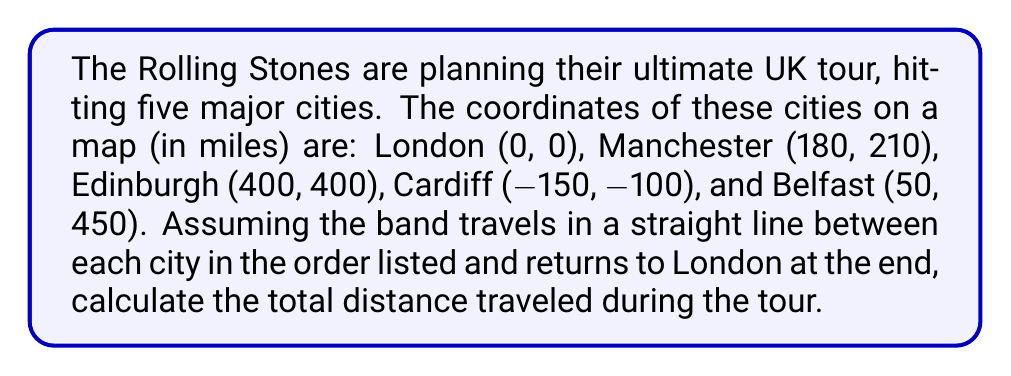What is the answer to this math problem? Let's approach this step-by-step using the distance formula between two points: $d = \sqrt{(x_2-x_1)^2 + (y_2-y_1)^2}$

1) London to Manchester:
   $d_1 = \sqrt{(180-0)^2 + (210-0)^2} = \sqrt{32400 + 44100} = \sqrt{76500} \approx 276.59$ miles

2) Manchester to Edinburgh:
   $d_2 = \sqrt{(400-180)^2 + (400-210)^2} = \sqrt{48400 + 36100} = \sqrt{84500} \approx 290.69$ miles

3) Edinburgh to Cardiff:
   $d_3 = \sqrt{(-150-400)^2 + (-100-400)^2} = \sqrt{302500 + 250000} = \sqrt{552500} \approx 743.30$ miles

4) Cardiff to Belfast:
   $d_4 = \sqrt{(50-(-150))^2 + (450-(-100))^2} = \sqrt{40000 + 302500} = \sqrt{342500} \approx 585.23$ miles

5) Belfast back to London:
   $d_5 = \sqrt{(0-50)^2 + (0-450)^2} = \sqrt{2500 + 202500} = \sqrt{205000} \approx 452.77$ miles

Total distance = $d_1 + d_2 + d_3 + d_4 + d_5$
                $\approx 276.59 + 290.69 + 743.30 + 585.23 + 452.77$
                $\approx 2348.58$ miles
Answer: $2348.58$ miles 